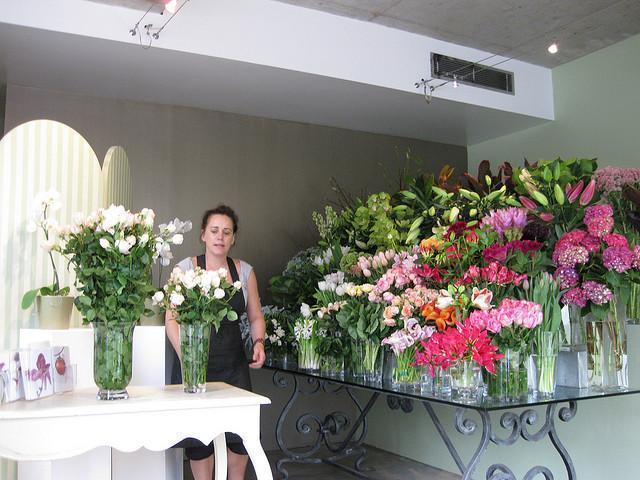How many vases can be seen?
Give a very brief answer. 2. How many potted plants are in the picture?
Give a very brief answer. 5. 